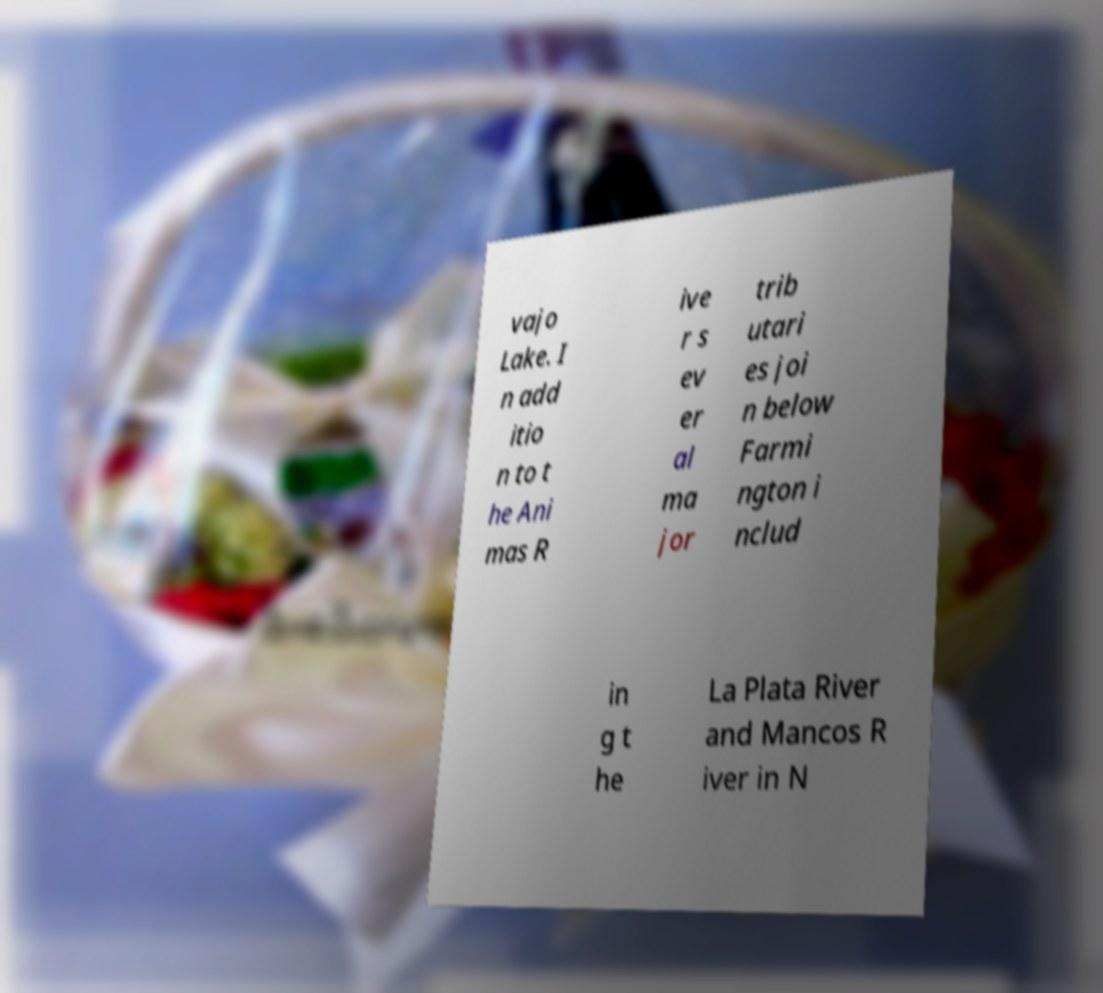Could you extract and type out the text from this image? vajo Lake. I n add itio n to t he Ani mas R ive r s ev er al ma jor trib utari es joi n below Farmi ngton i nclud in g t he La Plata River and Mancos R iver in N 